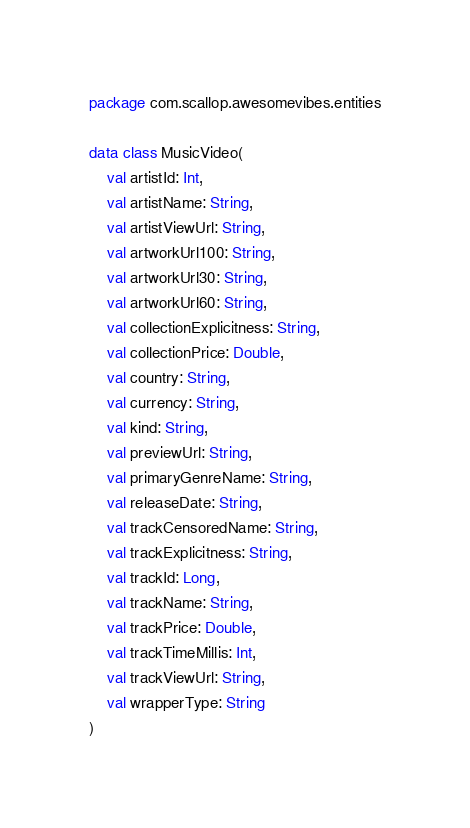<code> <loc_0><loc_0><loc_500><loc_500><_Kotlin_>package com.scallop.awesomevibes.entities

data class MusicVideo(
    val artistId: Int,
    val artistName: String,
    val artistViewUrl: String,
    val artworkUrl100: String,
    val artworkUrl30: String,
    val artworkUrl60: String,
    val collectionExplicitness: String,
    val collectionPrice: Double,
    val country: String,
    val currency: String,
    val kind: String,
    val previewUrl: String,
    val primaryGenreName: String,
    val releaseDate: String,
    val trackCensoredName: String,
    val trackExplicitness: String,
    val trackId: Long,
    val trackName: String,
    val trackPrice: Double,
    val trackTimeMillis: Int,
    val trackViewUrl: String,
    val wrapperType: String
)</code> 